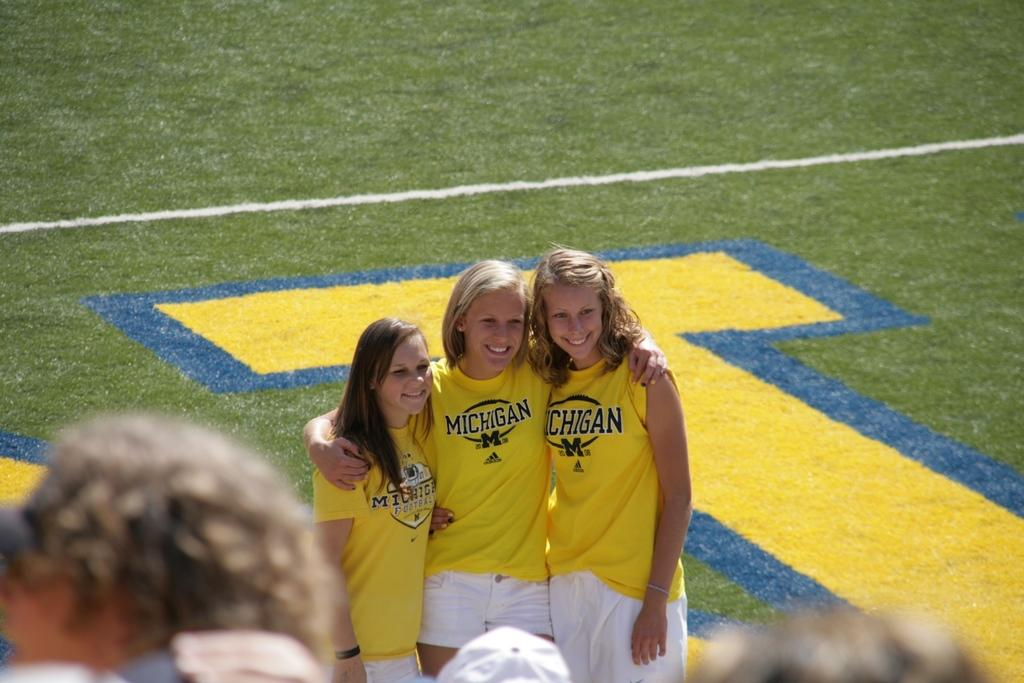How many people are standing and smiling in the center of the image? There are three people standing and smiling in the center of the image. What is happening at the bottom of the image? There are people at the bottom of the image. What can be seen in the background of the image? There is a field visible in the background of the image. What type of tooth is visible in the image? There is no tooth visible in the image. What cable is being used by the people in the image? There is no cable present in the image. 